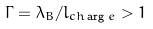Convert formula to latex. <formula><loc_0><loc_0><loc_500><loc_500>\Gamma = \lambda _ { B } / l _ { c h \arg e } > 1</formula> 